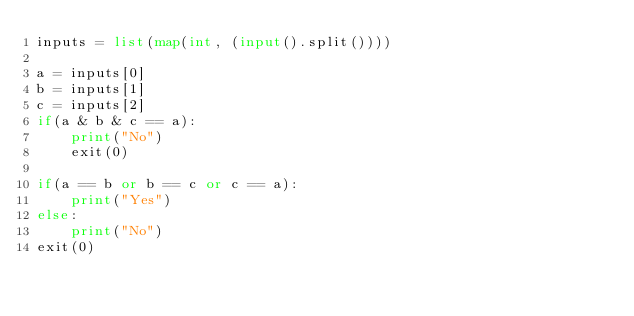Convert code to text. <code><loc_0><loc_0><loc_500><loc_500><_Python_>inputs = list(map(int, (input().split())))

a = inputs[0]
b = inputs[1]
c = inputs[2]
if(a & b & c == a):
    print("No")
    exit(0)

if(a == b or b == c or c == a):
    print("Yes")
else:
    print("No")
exit(0)
</code> 